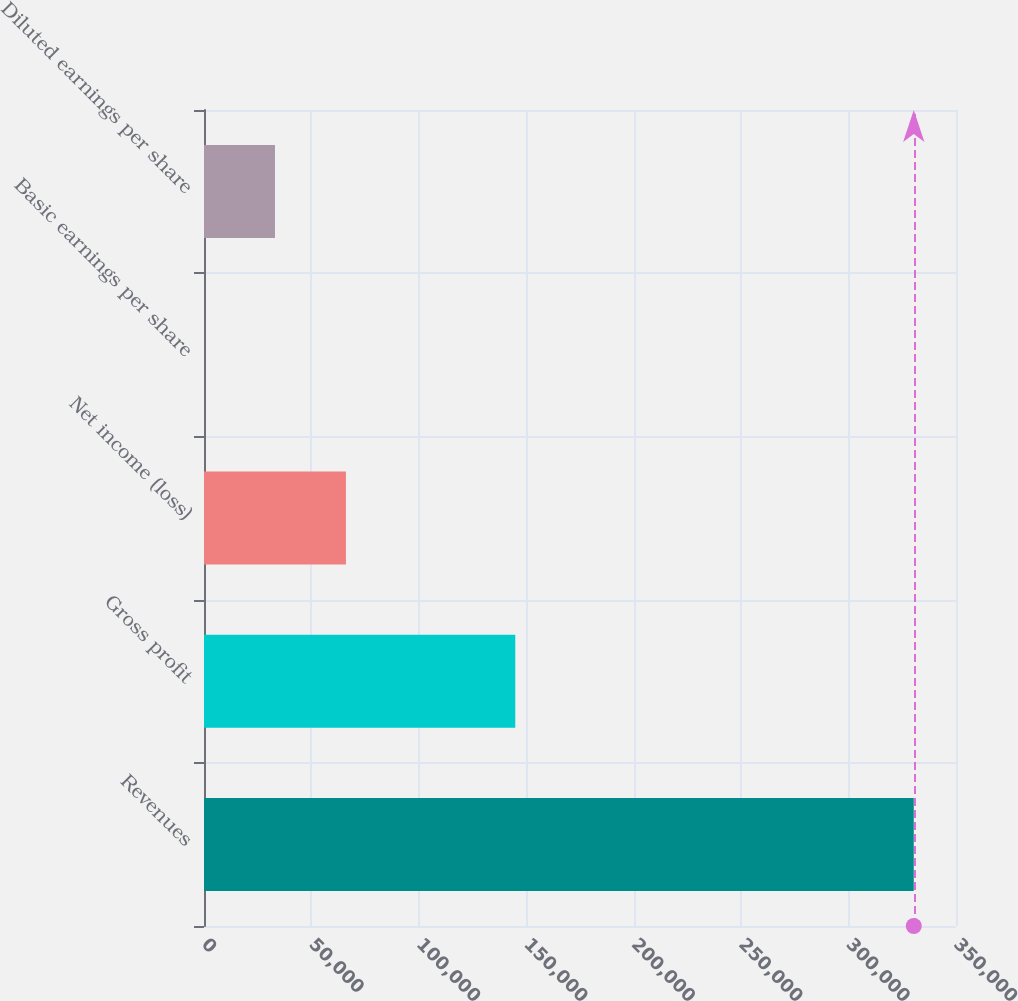<chart> <loc_0><loc_0><loc_500><loc_500><bar_chart><fcel>Revenues<fcel>Gross profit<fcel>Net income (loss)<fcel>Basic earnings per share<fcel>Diluted earnings per share<nl><fcel>330347<fcel>144871<fcel>66069.6<fcel>0.24<fcel>33034.9<nl></chart> 